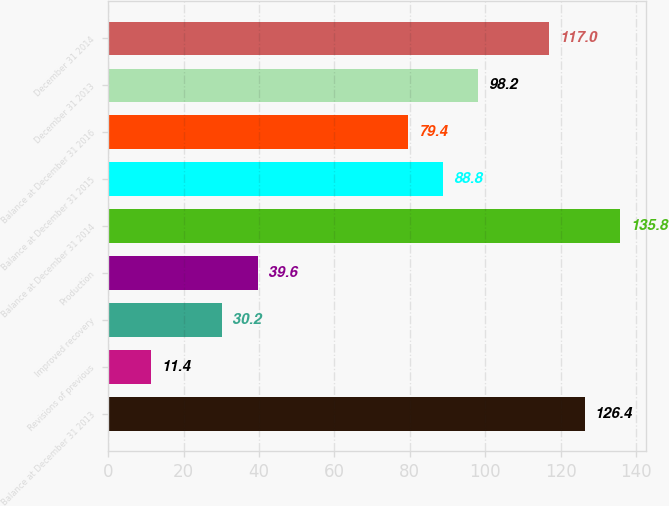<chart> <loc_0><loc_0><loc_500><loc_500><bar_chart><fcel>Balance at December 31 2013<fcel>Revisions of previous<fcel>Improved recovery<fcel>Production<fcel>Balance at December 31 2014<fcel>Balance at December 31 2015<fcel>Balance at December 31 2016<fcel>December 31 2013<fcel>December 31 2014<nl><fcel>126.4<fcel>11.4<fcel>30.2<fcel>39.6<fcel>135.8<fcel>88.8<fcel>79.4<fcel>98.2<fcel>117<nl></chart> 